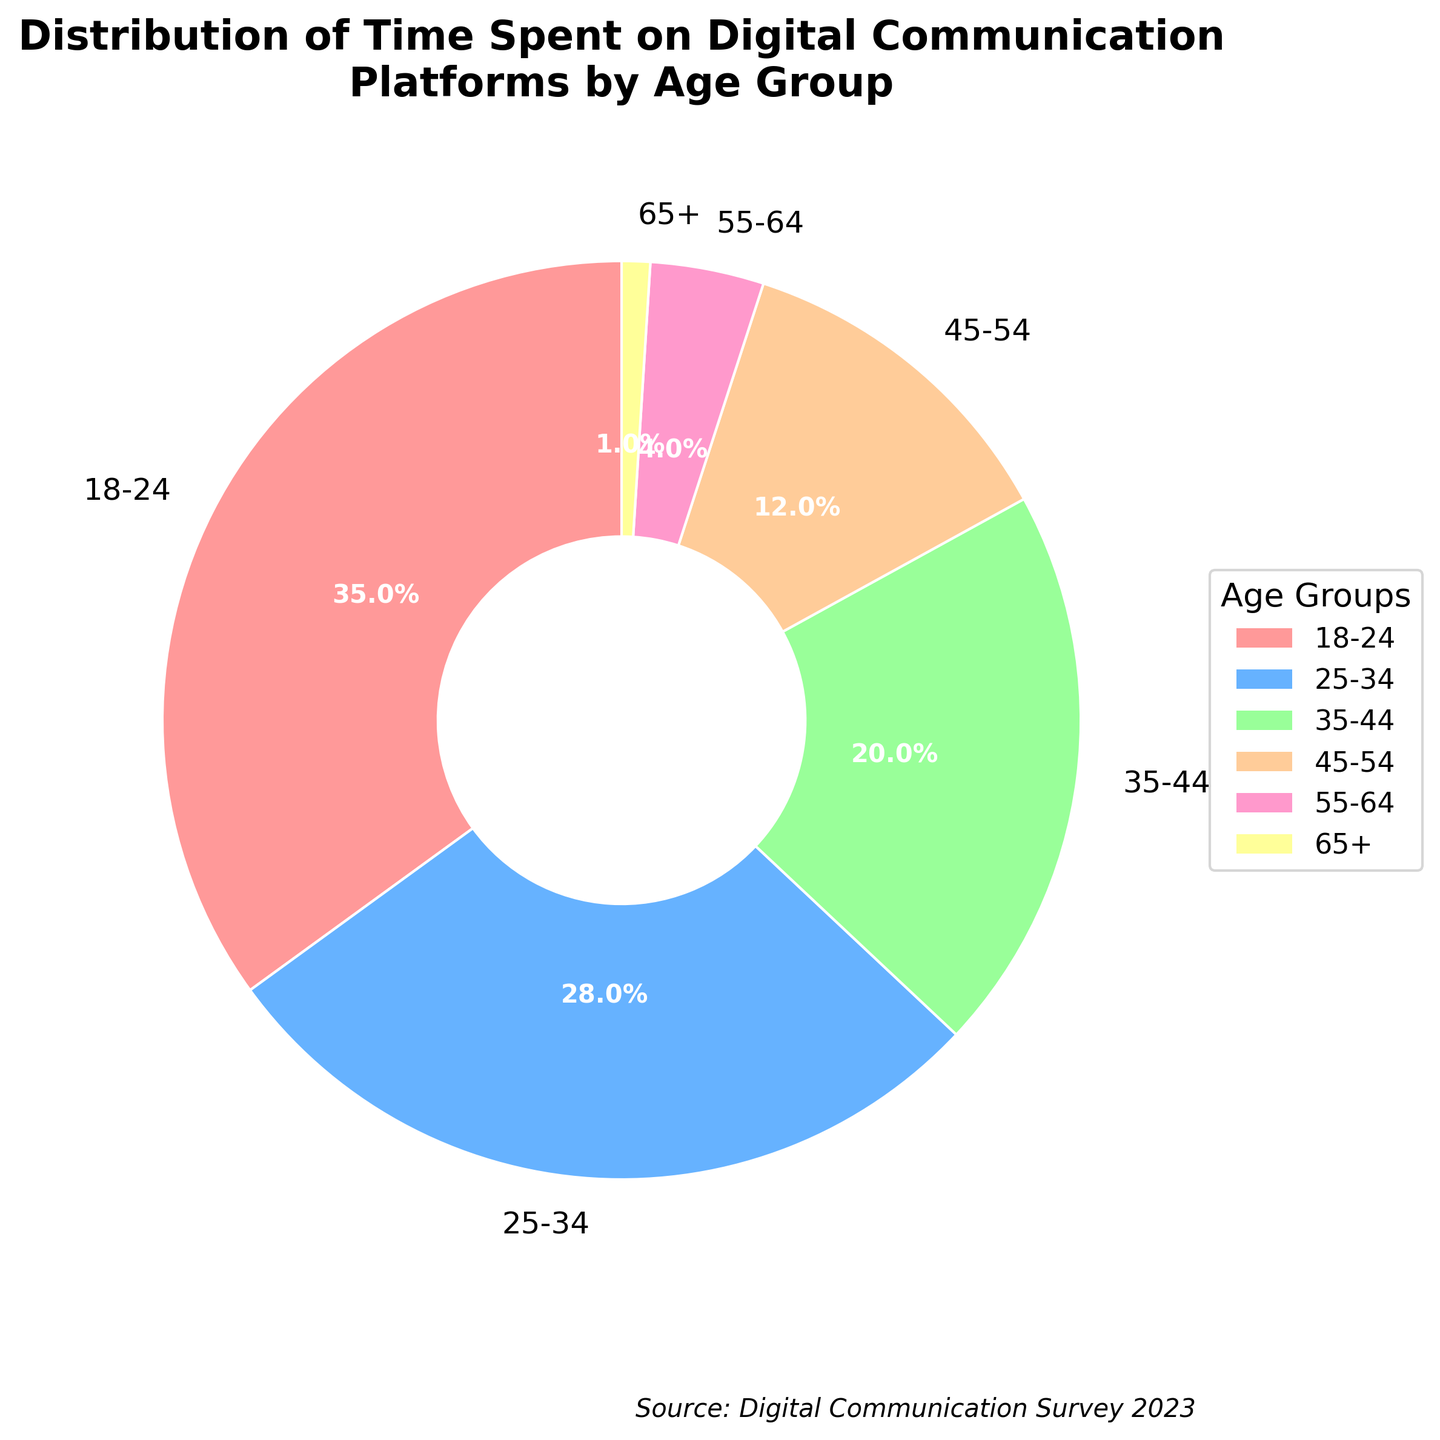What percentage of total time is spent by the 18-24 and 25-34 age groups combined? Add the percentages for the 18-24 and 25-34 age groups: 35% + 28% = 63%.
Answer: 63% Which age group spends the least amount of time on digital communication platforms? The smallest percentage is 1%, which corresponds to the 65+ age group.
Answer: 65+ How much more time does the 18-24 age group spend on digital communication platforms compared to the 55-64 age group? Subtract the percentage of the 55-64 age group from that of the 18-24 age group: 35% - 4% = 31%.
Answer: 31% What is the difference in percentage points between the time spent by the 35-44 age group and the 25-34 age group? Subtract the percentage of the 25-34 age group from that of the 35-44 age group: 28% - 20% = 8%.
Answer: 8% Which age group(s) spends more than 20% of their time on digital communication platforms? Age groups with percentages above 20% are the 18-24 (35%) and 25-34 (28%) age groups.
Answer: 18-24, 25-34 What is the average percentage of time spent on digital communication platforms by the age groups 18-24, 35-44, and 55-64? (35% + 20% + 4%) / 3 = 59% / 3 ≈ 19.67%.
Answer: 19.67% By how many percentage points does the time spent on digital communication platforms by the 45-54 age group differ from the average time spent by all age groups combined? First calculate the total average of all age groups: (35% + 28% + 20% + 12% + 4% + 1%) / 6 ≈ 100% / 6 ≈ 16.67%. The difference is 12% - 16.67% ≈ -4.67 percentage points.
Answer: -4.67 percentage points Which age group spends a higher percentage of their time on digital communication platforms: the 35-44 or the 45-54 age group? The 35-44 age group spends 20%, while the 45-54 age group spends 12%. 20% > 12%.
Answer: 35-44 